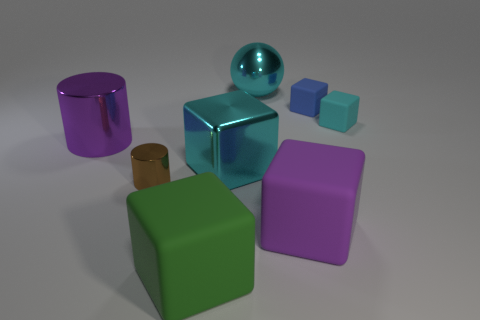Which objects in the image appear to be the most reflective? The most reflective objects in the image are the two metallic spheres. One is larger and exhibits a cyan color, while the other is smaller and shares the same hue. Their reflective surfaces are clearly mirroring the environment around them. 